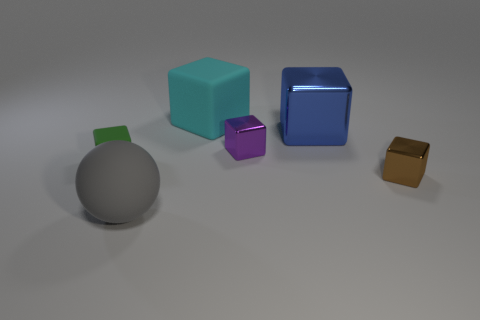Subtract 1 cubes. How many cubes are left? 4 Subtract all tiny purple blocks. How many blocks are left? 4 Subtract all blue cubes. How many cubes are left? 4 Subtract all red cubes. Subtract all purple cylinders. How many cubes are left? 5 Add 4 large rubber spheres. How many objects exist? 10 Subtract all balls. How many objects are left? 5 Add 4 small green matte blocks. How many small green matte blocks exist? 5 Subtract 0 blue cylinders. How many objects are left? 6 Subtract all small purple shiny objects. Subtract all green blocks. How many objects are left? 4 Add 3 green things. How many green things are left? 4 